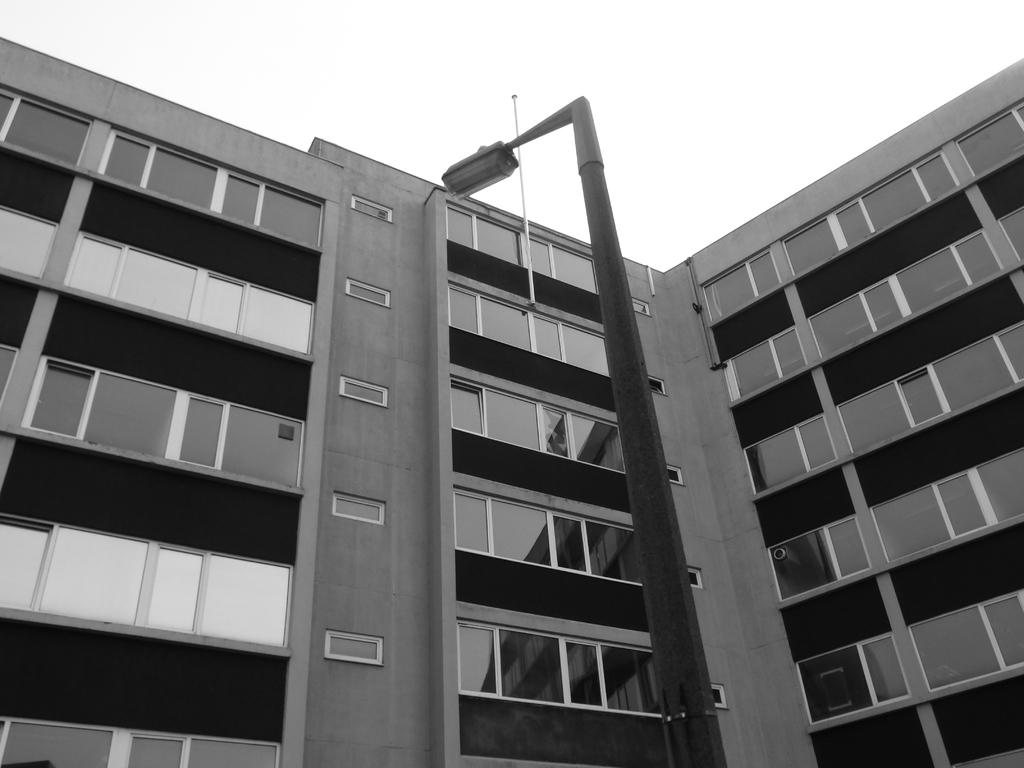What type of structure is present in the image? There is a building in the image. What else can be seen near the building? There is an electric pole with a light in the image. What is visible in the background of the image? The sky is visible in the background of the image. How many cakes are being shared in harmony by the cannon in the image? There is no cannon or cakes present in the image. 